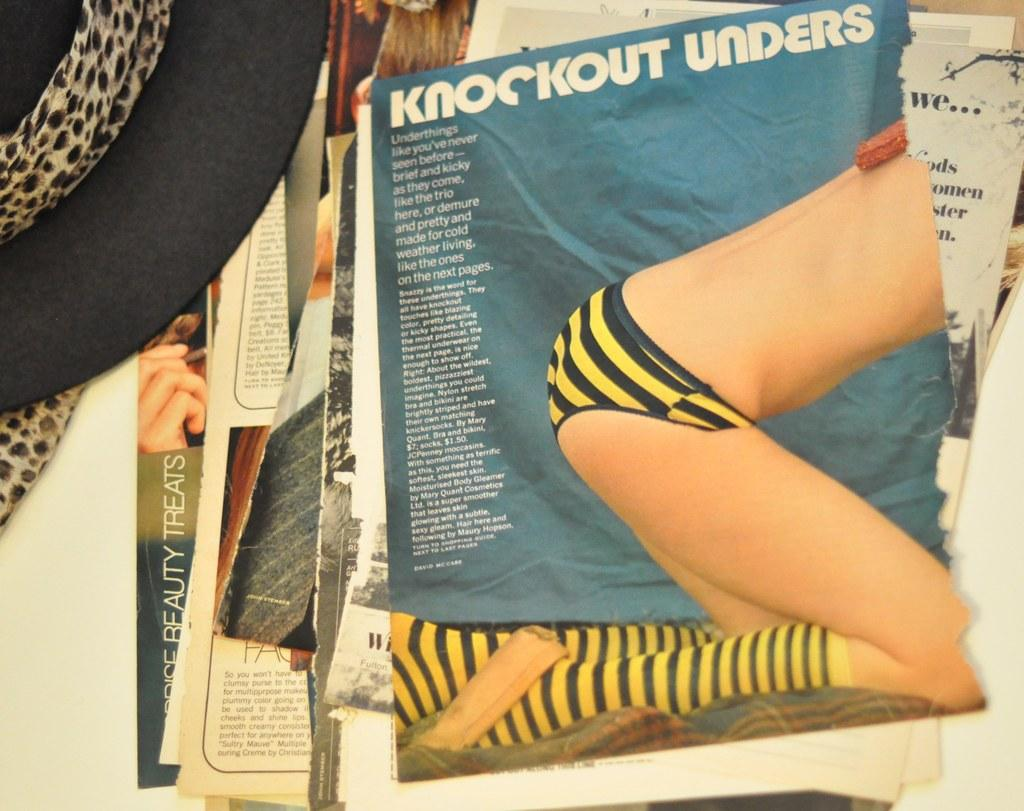Provide a one-sentence caption for the provided image. The magazine article has the title Knockout Unders. 